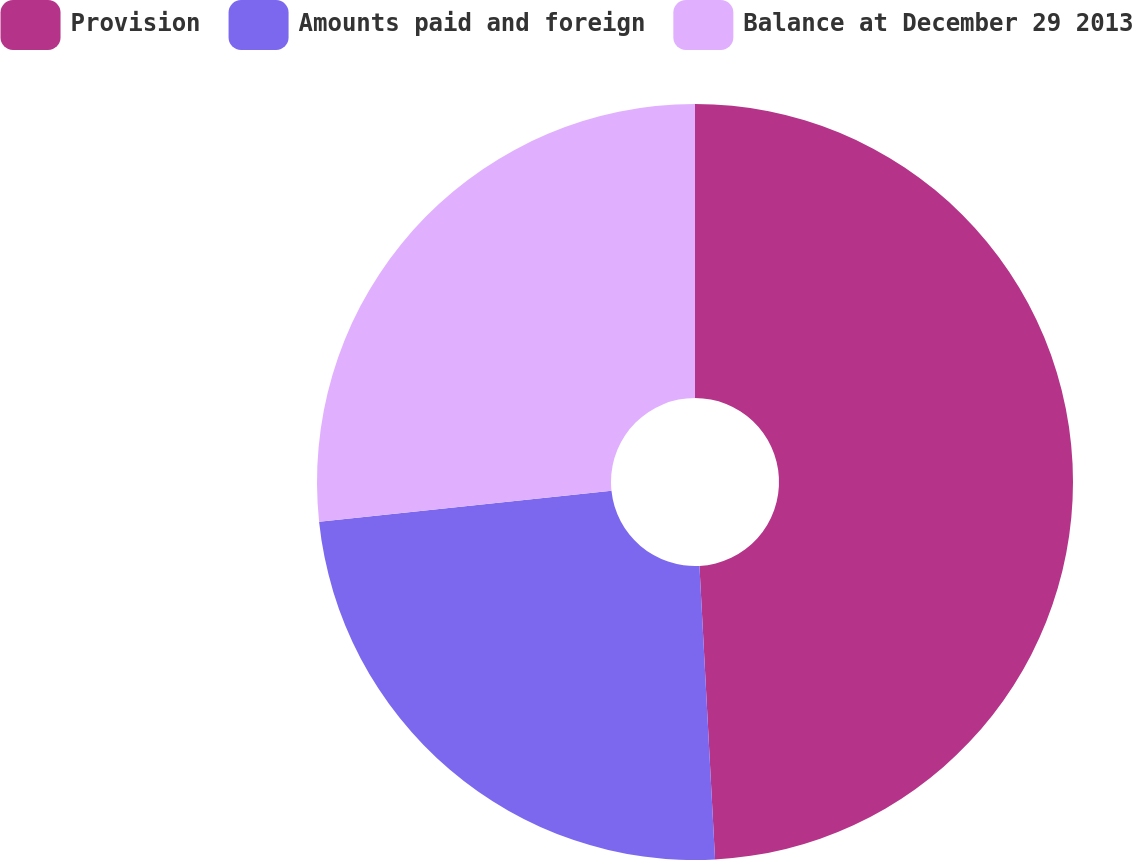Convert chart. <chart><loc_0><loc_0><loc_500><loc_500><pie_chart><fcel>Provision<fcel>Amounts paid and foreign<fcel>Balance at December 29 2013<nl><fcel>49.15%<fcel>24.17%<fcel>26.67%<nl></chart> 